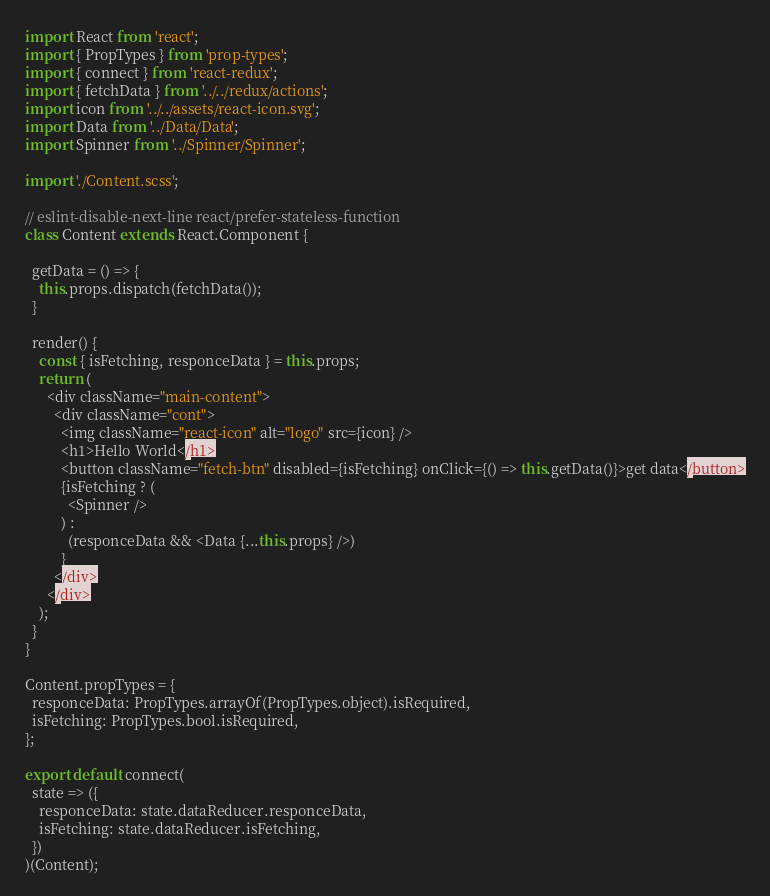<code> <loc_0><loc_0><loc_500><loc_500><_JavaScript_>import React from 'react';
import { PropTypes } from 'prop-types';
import { connect } from 'react-redux';
import { fetchData } from '../../redux/actions';
import icon from '../../assets/react-icon.svg';
import Data from '../Data/Data';
import Spinner from '../Spinner/Spinner';

import './Content.scss';

// eslint-disable-next-line react/prefer-stateless-function
class Content extends React.Component {

  getData = () => {
    this.props.dispatch(fetchData());
  }

  render() {
    const { isFetching, responceData } = this.props;
    return (
      <div className="main-content">
        <div className="cont">
          <img className="react-icon" alt="logo" src={icon} />
          <h1>Hello World</h1>
          <button className="fetch-btn" disabled={isFetching} onClick={() => this.getData()}>get data</button>
          {isFetching ? (
            <Spinner />
          ) :
            (responceData && <Data {...this.props} />)
          }
        </div>
      </div>
    );
  }
}

Content.propTypes = {
  responceData: PropTypes.arrayOf(PropTypes.object).isRequired,
  isFetching: PropTypes.bool.isRequired,
};

export default connect(
  state => ({
    responceData: state.dataReducer.responceData,
    isFetching: state.dataReducer.isFetching,
  })
)(Content);
</code> 